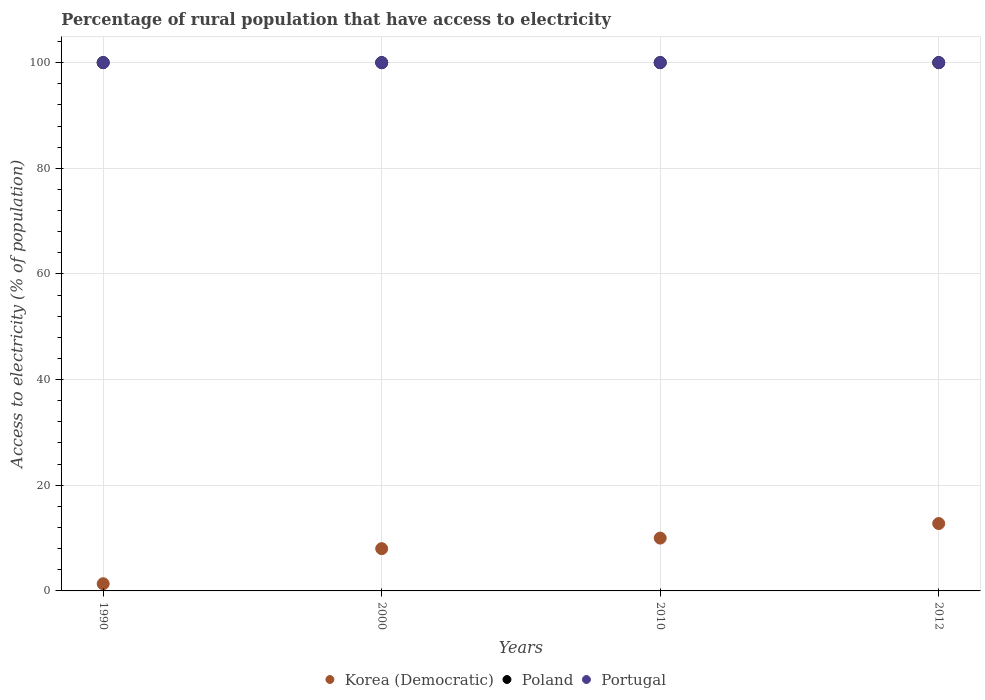What is the percentage of rural population that have access to electricity in Korea (Democratic) in 2010?
Your answer should be very brief. 10. Across all years, what is the maximum percentage of rural population that have access to electricity in Poland?
Give a very brief answer. 100. Across all years, what is the minimum percentage of rural population that have access to electricity in Korea (Democratic)?
Your response must be concise. 1.36. In which year was the percentage of rural population that have access to electricity in Korea (Democratic) minimum?
Keep it short and to the point. 1990. What is the total percentage of rural population that have access to electricity in Portugal in the graph?
Your response must be concise. 400. What is the difference between the percentage of rural population that have access to electricity in Poland in 2000 and that in 2010?
Your response must be concise. 0. What is the difference between the percentage of rural population that have access to electricity in Korea (Democratic) in 2000 and the percentage of rural population that have access to electricity in Portugal in 1990?
Make the answer very short. -92. In the year 2012, what is the difference between the percentage of rural population that have access to electricity in Poland and percentage of rural population that have access to electricity in Portugal?
Your answer should be compact. 0. In how many years, is the percentage of rural population that have access to electricity in Korea (Democratic) greater than 24 %?
Give a very brief answer. 0. Is the percentage of rural population that have access to electricity in Poland in 1990 less than that in 2012?
Your response must be concise. No. Is the difference between the percentage of rural population that have access to electricity in Poland in 1990 and 2000 greater than the difference between the percentage of rural population that have access to electricity in Portugal in 1990 and 2000?
Offer a terse response. No. What is the difference between the highest and the lowest percentage of rural population that have access to electricity in Portugal?
Make the answer very short. 0. Is it the case that in every year, the sum of the percentage of rural population that have access to electricity in Korea (Democratic) and percentage of rural population that have access to electricity in Portugal  is greater than the percentage of rural population that have access to electricity in Poland?
Your answer should be compact. Yes. How many dotlines are there?
Provide a short and direct response. 3. How many years are there in the graph?
Your answer should be very brief. 4. Are the values on the major ticks of Y-axis written in scientific E-notation?
Provide a short and direct response. No. Where does the legend appear in the graph?
Ensure brevity in your answer.  Bottom center. How many legend labels are there?
Your response must be concise. 3. What is the title of the graph?
Provide a short and direct response. Percentage of rural population that have access to electricity. Does "Mali" appear as one of the legend labels in the graph?
Offer a terse response. No. What is the label or title of the X-axis?
Your answer should be very brief. Years. What is the label or title of the Y-axis?
Keep it short and to the point. Access to electricity (% of population). What is the Access to electricity (% of population) in Korea (Democratic) in 1990?
Give a very brief answer. 1.36. What is the Access to electricity (% of population) of Poland in 1990?
Offer a very short reply. 100. What is the Access to electricity (% of population) in Portugal in 1990?
Keep it short and to the point. 100. What is the Access to electricity (% of population) in Korea (Democratic) in 2000?
Ensure brevity in your answer.  8. What is the Access to electricity (% of population) in Portugal in 2000?
Ensure brevity in your answer.  100. What is the Access to electricity (% of population) of Poland in 2010?
Your answer should be very brief. 100. What is the Access to electricity (% of population) in Portugal in 2010?
Give a very brief answer. 100. What is the Access to electricity (% of population) in Korea (Democratic) in 2012?
Provide a succinct answer. 12.75. What is the Access to electricity (% of population) in Poland in 2012?
Your response must be concise. 100. What is the Access to electricity (% of population) in Portugal in 2012?
Offer a very short reply. 100. Across all years, what is the maximum Access to electricity (% of population) of Korea (Democratic)?
Give a very brief answer. 12.75. Across all years, what is the minimum Access to electricity (% of population) in Korea (Democratic)?
Make the answer very short. 1.36. What is the total Access to electricity (% of population) in Korea (Democratic) in the graph?
Offer a terse response. 32.11. What is the total Access to electricity (% of population) in Poland in the graph?
Offer a terse response. 400. What is the difference between the Access to electricity (% of population) in Korea (Democratic) in 1990 and that in 2000?
Keep it short and to the point. -6.64. What is the difference between the Access to electricity (% of population) of Poland in 1990 and that in 2000?
Ensure brevity in your answer.  0. What is the difference between the Access to electricity (% of population) of Portugal in 1990 and that in 2000?
Your answer should be very brief. 0. What is the difference between the Access to electricity (% of population) of Korea (Democratic) in 1990 and that in 2010?
Provide a short and direct response. -8.64. What is the difference between the Access to electricity (% of population) in Poland in 1990 and that in 2010?
Make the answer very short. 0. What is the difference between the Access to electricity (% of population) of Portugal in 1990 and that in 2010?
Your answer should be compact. 0. What is the difference between the Access to electricity (% of population) in Korea (Democratic) in 1990 and that in 2012?
Keep it short and to the point. -11.39. What is the difference between the Access to electricity (% of population) in Poland in 1990 and that in 2012?
Offer a very short reply. 0. What is the difference between the Access to electricity (% of population) in Portugal in 1990 and that in 2012?
Keep it short and to the point. 0. What is the difference between the Access to electricity (% of population) of Korea (Democratic) in 2000 and that in 2010?
Provide a succinct answer. -2. What is the difference between the Access to electricity (% of population) of Portugal in 2000 and that in 2010?
Your response must be concise. 0. What is the difference between the Access to electricity (% of population) in Korea (Democratic) in 2000 and that in 2012?
Provide a short and direct response. -4.75. What is the difference between the Access to electricity (% of population) of Poland in 2000 and that in 2012?
Your response must be concise. 0. What is the difference between the Access to electricity (% of population) in Korea (Democratic) in 2010 and that in 2012?
Your answer should be compact. -2.75. What is the difference between the Access to electricity (% of population) in Poland in 2010 and that in 2012?
Offer a very short reply. 0. What is the difference between the Access to electricity (% of population) in Portugal in 2010 and that in 2012?
Provide a succinct answer. 0. What is the difference between the Access to electricity (% of population) of Korea (Democratic) in 1990 and the Access to electricity (% of population) of Poland in 2000?
Your answer should be very brief. -98.64. What is the difference between the Access to electricity (% of population) of Korea (Democratic) in 1990 and the Access to electricity (% of population) of Portugal in 2000?
Your answer should be very brief. -98.64. What is the difference between the Access to electricity (% of population) in Poland in 1990 and the Access to electricity (% of population) in Portugal in 2000?
Your answer should be very brief. 0. What is the difference between the Access to electricity (% of population) in Korea (Democratic) in 1990 and the Access to electricity (% of population) in Poland in 2010?
Give a very brief answer. -98.64. What is the difference between the Access to electricity (% of population) in Korea (Democratic) in 1990 and the Access to electricity (% of population) in Portugal in 2010?
Provide a short and direct response. -98.64. What is the difference between the Access to electricity (% of population) of Poland in 1990 and the Access to electricity (% of population) of Portugal in 2010?
Give a very brief answer. 0. What is the difference between the Access to electricity (% of population) of Korea (Democratic) in 1990 and the Access to electricity (% of population) of Poland in 2012?
Offer a terse response. -98.64. What is the difference between the Access to electricity (% of population) in Korea (Democratic) in 1990 and the Access to electricity (% of population) in Portugal in 2012?
Provide a succinct answer. -98.64. What is the difference between the Access to electricity (% of population) in Poland in 1990 and the Access to electricity (% of population) in Portugal in 2012?
Your response must be concise. 0. What is the difference between the Access to electricity (% of population) of Korea (Democratic) in 2000 and the Access to electricity (% of population) of Poland in 2010?
Offer a very short reply. -92. What is the difference between the Access to electricity (% of population) of Korea (Democratic) in 2000 and the Access to electricity (% of population) of Portugal in 2010?
Offer a very short reply. -92. What is the difference between the Access to electricity (% of population) of Korea (Democratic) in 2000 and the Access to electricity (% of population) of Poland in 2012?
Keep it short and to the point. -92. What is the difference between the Access to electricity (% of population) of Korea (Democratic) in 2000 and the Access to electricity (% of population) of Portugal in 2012?
Your response must be concise. -92. What is the difference between the Access to electricity (% of population) of Korea (Democratic) in 2010 and the Access to electricity (% of population) of Poland in 2012?
Give a very brief answer. -90. What is the difference between the Access to electricity (% of population) of Korea (Democratic) in 2010 and the Access to electricity (% of population) of Portugal in 2012?
Ensure brevity in your answer.  -90. What is the average Access to electricity (% of population) in Korea (Democratic) per year?
Your response must be concise. 8.03. What is the average Access to electricity (% of population) in Poland per year?
Offer a very short reply. 100. What is the average Access to electricity (% of population) in Portugal per year?
Give a very brief answer. 100. In the year 1990, what is the difference between the Access to electricity (% of population) of Korea (Democratic) and Access to electricity (% of population) of Poland?
Give a very brief answer. -98.64. In the year 1990, what is the difference between the Access to electricity (% of population) in Korea (Democratic) and Access to electricity (% of population) in Portugal?
Keep it short and to the point. -98.64. In the year 1990, what is the difference between the Access to electricity (% of population) of Poland and Access to electricity (% of population) of Portugal?
Give a very brief answer. 0. In the year 2000, what is the difference between the Access to electricity (% of population) in Korea (Democratic) and Access to electricity (% of population) in Poland?
Ensure brevity in your answer.  -92. In the year 2000, what is the difference between the Access to electricity (% of population) in Korea (Democratic) and Access to electricity (% of population) in Portugal?
Make the answer very short. -92. In the year 2000, what is the difference between the Access to electricity (% of population) in Poland and Access to electricity (% of population) in Portugal?
Give a very brief answer. 0. In the year 2010, what is the difference between the Access to electricity (% of population) of Korea (Democratic) and Access to electricity (% of population) of Poland?
Make the answer very short. -90. In the year 2010, what is the difference between the Access to electricity (% of population) of Korea (Democratic) and Access to electricity (% of population) of Portugal?
Your response must be concise. -90. In the year 2012, what is the difference between the Access to electricity (% of population) in Korea (Democratic) and Access to electricity (% of population) in Poland?
Provide a succinct answer. -87.25. In the year 2012, what is the difference between the Access to electricity (% of population) in Korea (Democratic) and Access to electricity (% of population) in Portugal?
Offer a very short reply. -87.25. What is the ratio of the Access to electricity (% of population) in Korea (Democratic) in 1990 to that in 2000?
Offer a terse response. 0.17. What is the ratio of the Access to electricity (% of population) of Poland in 1990 to that in 2000?
Your answer should be very brief. 1. What is the ratio of the Access to electricity (% of population) in Portugal in 1990 to that in 2000?
Your answer should be very brief. 1. What is the ratio of the Access to electricity (% of population) of Korea (Democratic) in 1990 to that in 2010?
Provide a succinct answer. 0.14. What is the ratio of the Access to electricity (% of population) of Poland in 1990 to that in 2010?
Your response must be concise. 1. What is the ratio of the Access to electricity (% of population) of Korea (Democratic) in 1990 to that in 2012?
Your answer should be very brief. 0.11. What is the ratio of the Access to electricity (% of population) of Poland in 2000 to that in 2010?
Your response must be concise. 1. What is the ratio of the Access to electricity (% of population) in Portugal in 2000 to that in 2010?
Your answer should be very brief. 1. What is the ratio of the Access to electricity (% of population) of Korea (Democratic) in 2000 to that in 2012?
Your answer should be very brief. 0.63. What is the ratio of the Access to electricity (% of population) in Poland in 2000 to that in 2012?
Your response must be concise. 1. What is the ratio of the Access to electricity (% of population) in Korea (Democratic) in 2010 to that in 2012?
Give a very brief answer. 0.78. What is the ratio of the Access to electricity (% of population) in Poland in 2010 to that in 2012?
Your answer should be compact. 1. What is the ratio of the Access to electricity (% of population) in Portugal in 2010 to that in 2012?
Offer a very short reply. 1. What is the difference between the highest and the second highest Access to electricity (% of population) in Korea (Democratic)?
Your response must be concise. 2.75. What is the difference between the highest and the lowest Access to electricity (% of population) in Korea (Democratic)?
Provide a succinct answer. 11.39. 